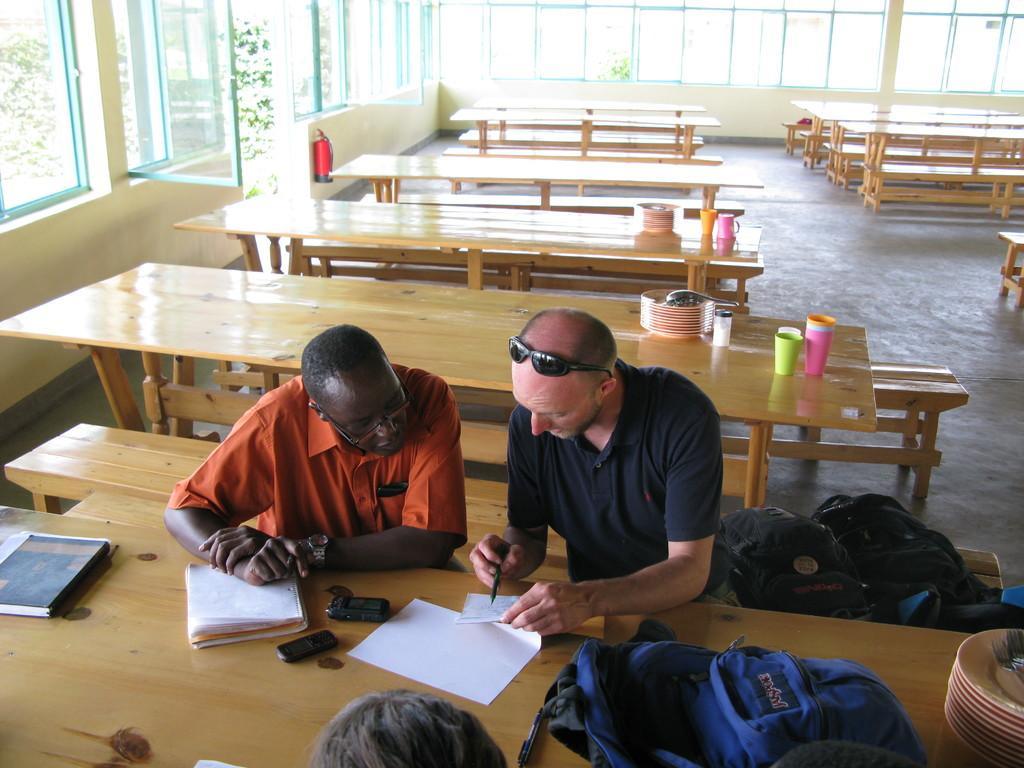Describe this image in one or two sentences. In the center we can see two persons they were sitting and the right side person he is holding paper and pen. On the table there are some objects. Coming to the background we can see some tables. 